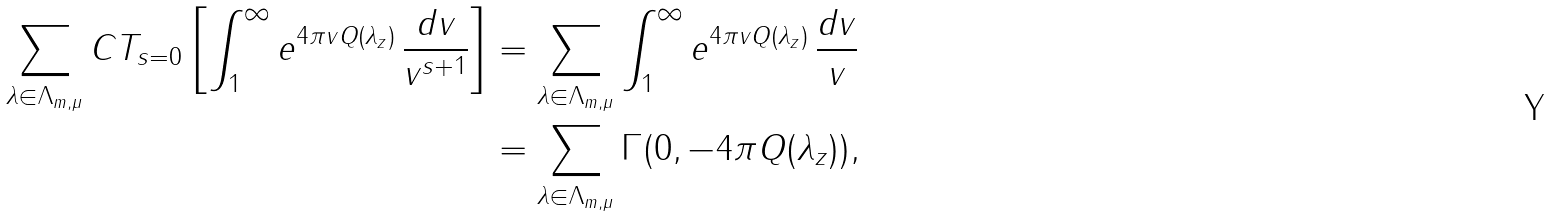Convert formula to latex. <formula><loc_0><loc_0><loc_500><loc_500>\sum _ { \lambda \in \Lambda _ { m , \mu } } C T _ { s = 0 } \left [ \int _ { 1 } ^ { \infty } e ^ { 4 \pi v Q ( \lambda _ { z } ) } \, \frac { d v } { v ^ { s + 1 } } \right ] & = \sum _ { \lambda \in \Lambda _ { m , \mu } } \int _ { 1 } ^ { \infty } e ^ { 4 \pi v Q ( \lambda _ { z } ) } \, \frac { d v } { v } \\ & = \sum _ { \lambda \in \Lambda _ { m , \mu } } \Gamma ( 0 , - 4 \pi Q ( \lambda _ { z } ) ) ,</formula> 